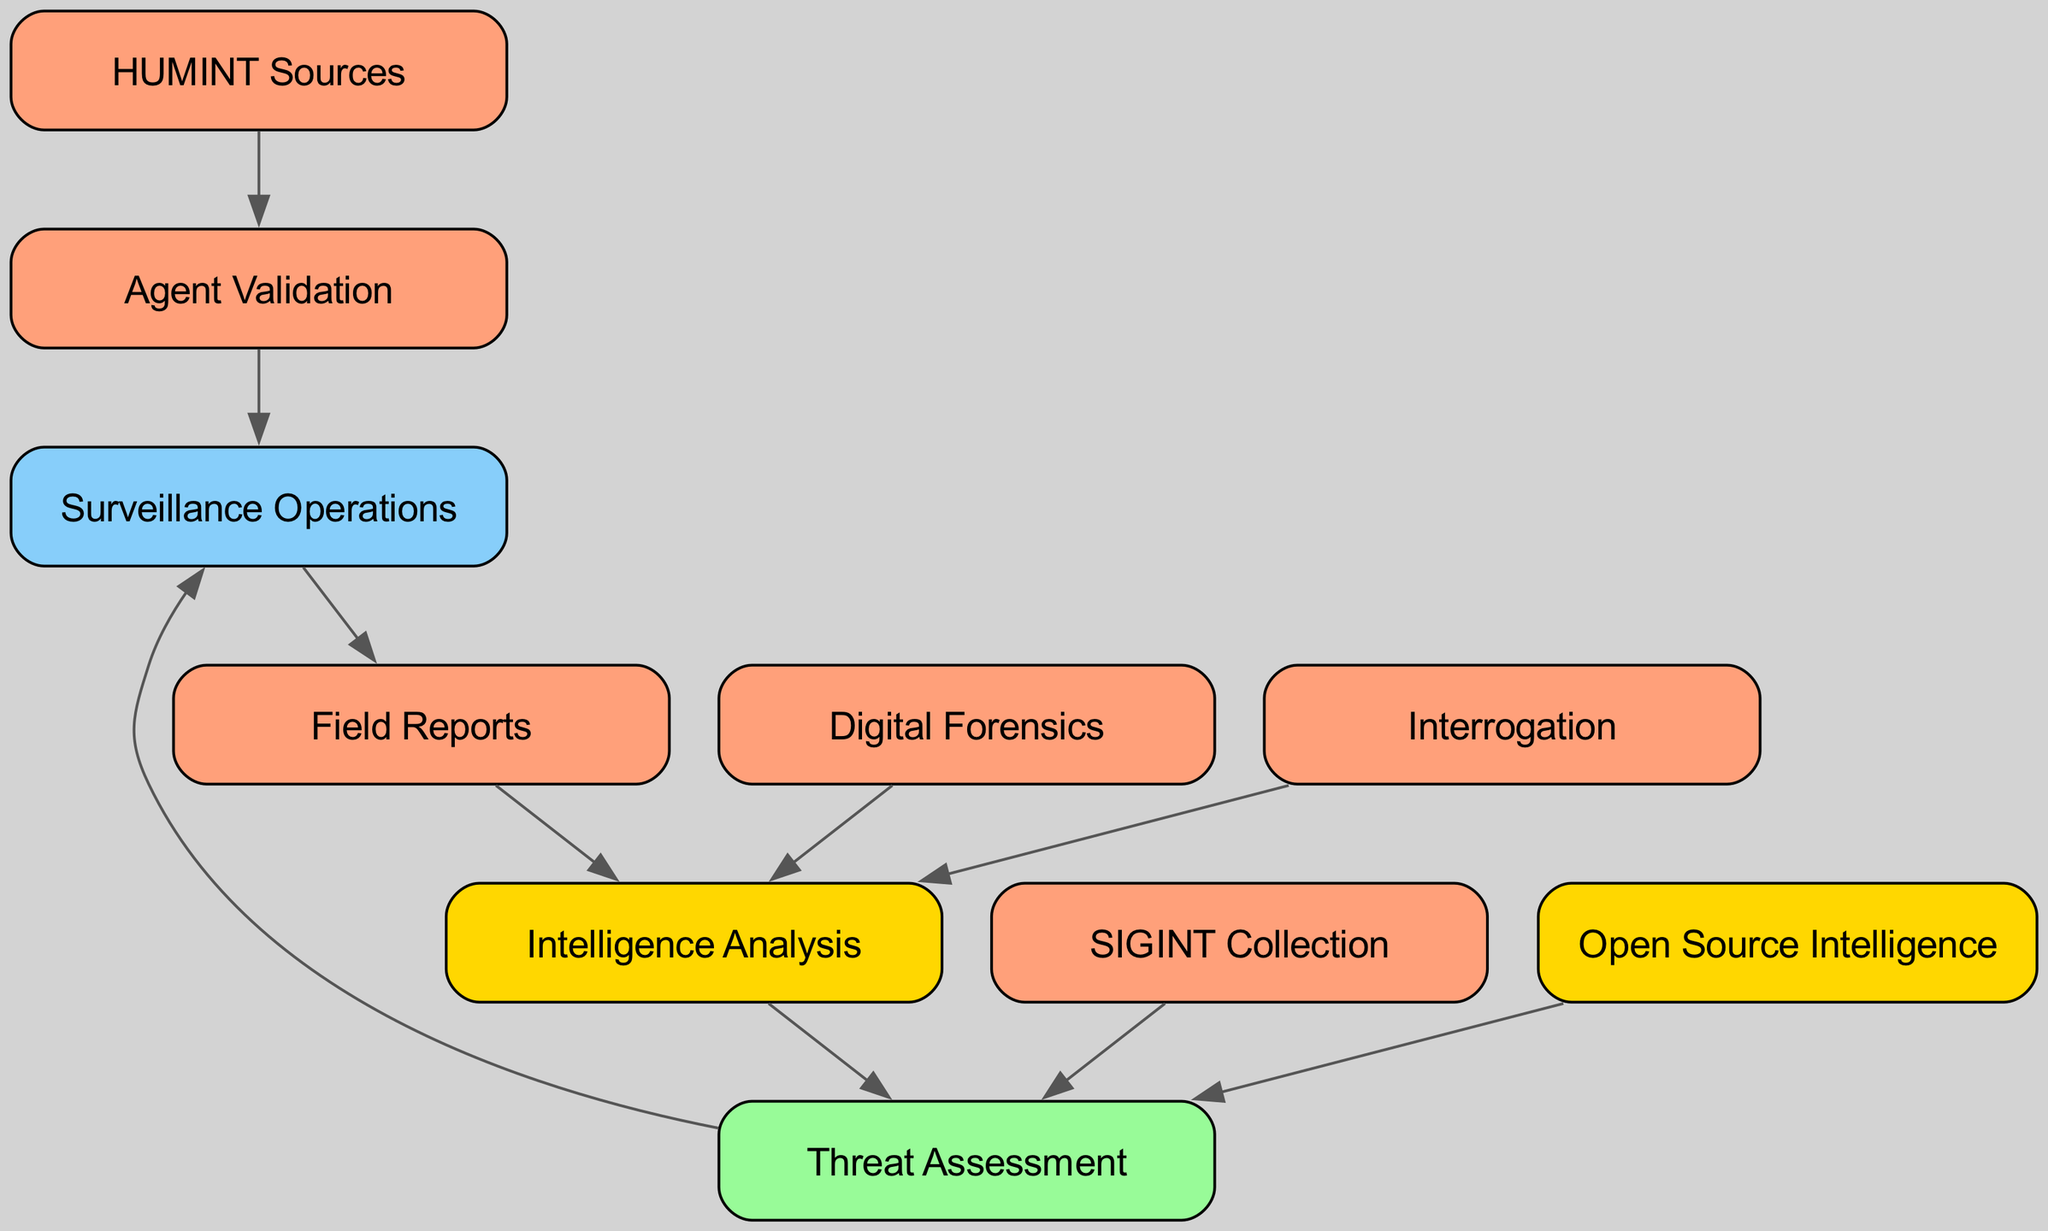What are the total number of nodes in the diagram? Counting the items listed in the "nodes" section, we find ten distinct sources of information involved in the counterintelligence investigation process.
Answer: 10 What is the source that leads to "Agent Validation"? The directed edge from "HUMINT Sources" points to "Agent Validation," indicating that this source is crucial for the validation of agents.
Answer: HUMINT Sources How many edges are linked to "Surveillance Operations"? "Surveillance Operations" has two incoming edges from "Agent Validation" and "Threat Assessment" and one outgoing edge to "Field Reports," making a total of three edges connecting to this node.
Answer: 3 Which node directly analyzes "Digital Forensics"? "Digital Forensics" points directly to "Intelligence Analysis," meaning that the information gathered in the digital forensics stage is analyzed by this node.
Answer: Intelligence Analysis From which nodes do we gather information to perform a "Threat Assessment"? Both "SIGINT Collection" and "Open Source Intelligence" contribute information to the "Threat Assessment," as they each have directed edges leading to this node.
Answer: SIGINT Collection, Open Source Intelligence What node follows after "Field Reports" in the diagram? The directed edge indicates that after "Field Reports," the information is processed by "Intelligence Analysis," making this the subsequent step in the investigation process.
Answer: Intelligence Analysis How is "Intelligence Analysis" related to "Threat Assessment"? "Intelligence Analysis" provides insights that inform "Threat Assessment," as indicated by the directed edge that flows from the former to the latter.
Answer: Provides insights How many nodes directly analyze information in the diagram? The nodes "Digital Forensics," "Interrogation," and "Field Reports" all link to "Intelligence Analysis," which means there are three nodes that lead to analysis in the diagram.
Answer: 3 What type of operations does "Agent Validation" connect to? "Agent Validation" connects to "Surveillance Operations," which indicates that validating agents is a prerequisite for conducting surveillance activities.
Answer: Surveillance Operations What color represents nodes related to intelligence in the diagram? The nodes identified as related to intelligence, specifically “Intelligence Analysis,” have a golden color.
Answer: Gold 